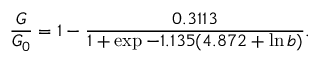<formula> <loc_0><loc_0><loc_500><loc_500>\frac { G } { G _ { 0 } } = 1 - \frac { 0 . 3 1 1 3 } { 1 + \exp { - 1 . 1 3 5 ( 4 . 8 7 2 + \ln b ) } } .</formula> 